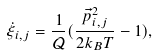Convert formula to latex. <formula><loc_0><loc_0><loc_500><loc_500>\dot { \xi } _ { i , j } = \frac { 1 } { \mathcal { Q } } ( \frac { \vec { p } _ { i , j } ^ { 2 } } { 2 k _ { B } T } - 1 ) ,</formula> 